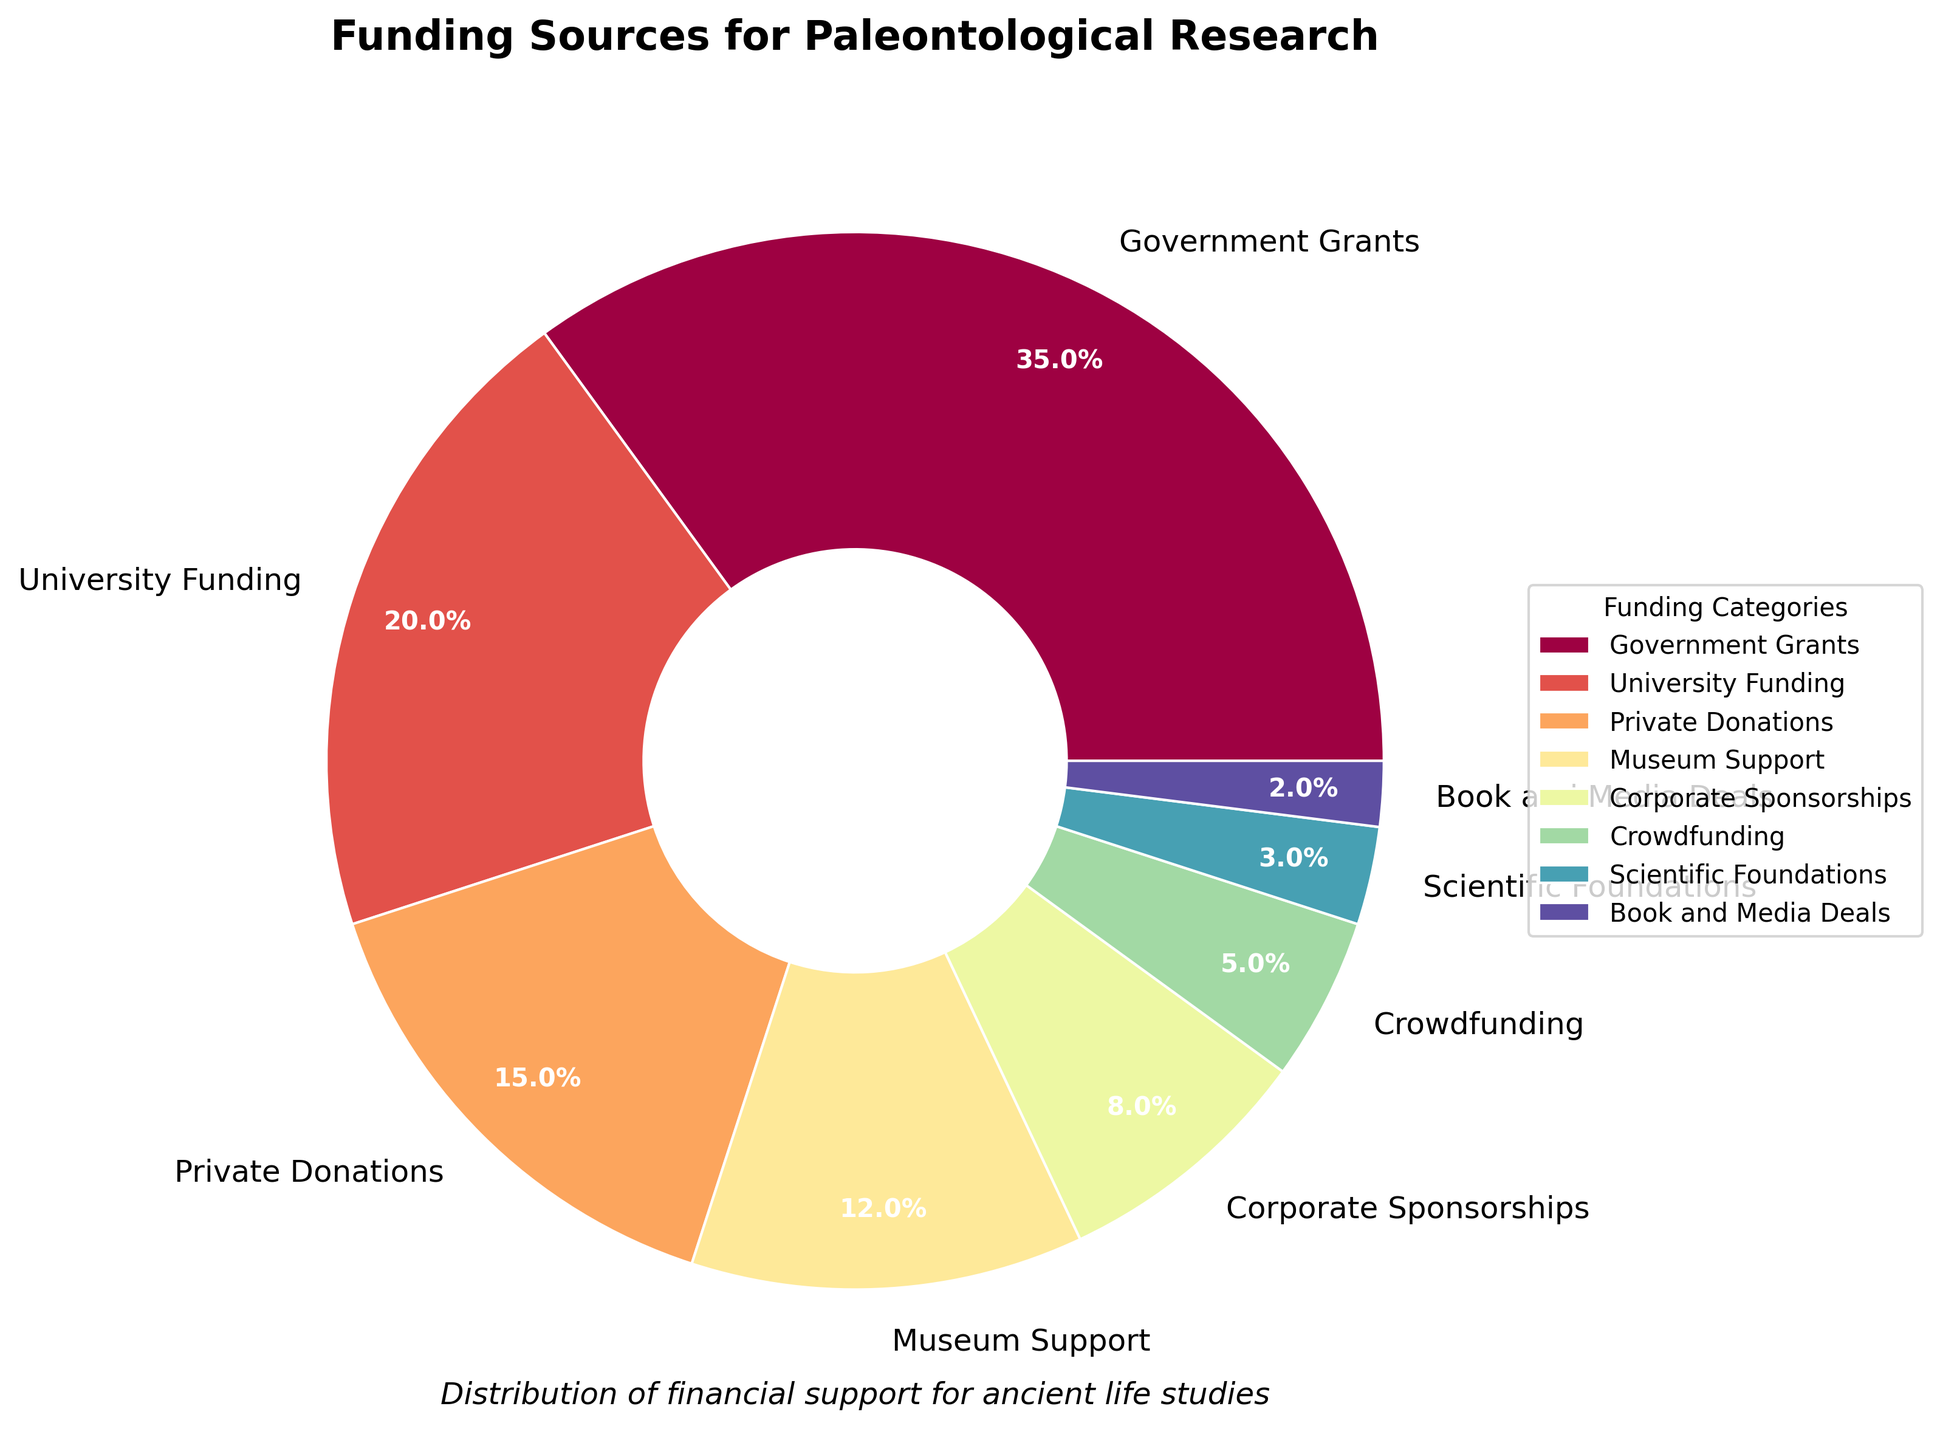What is the largest funding source for paleontological research? The largest funding source is the one with the highest percentage. According to the pie chart, Government Grants constitute 35%, which is the highest.
Answer: Government Grants Which two funding sources together make up more than half of the total funding? To find this, add the percentages of the categories and see if they exceed 50%. The two largest percentages are Government Grants (35%) and University Funding (20%). Their sum is 35% + 20% = 55%, which is more than half.
Answer: Government Grants and University Funding How many funding sources provide less than 10%? Count the funding sources with percentages less than 10%. These are Corporate Sponsorships (8%), Crowdfunding (5%), Scientific Foundations (3%), and Book and Media Deals (2%). There are 4 such sources.
Answer: 4 Which funding source is represented by the smallest wedge in the pie chart? The smallest wedge corresponds to the smallest percentage. According to the pie chart, Book and Media Deals have the smallest wedge with 2%.
Answer: Book and Media Deals What is the total percentage provided by private (non-governmental) sources? Add up the percentages of all private funding sources. These include University Funding (20%), Private Donations (15%), Museum Support (12%), Corporate Sponsorships (8%), Crowdfunding (5%), Scientific Foundations (3%), and Book and Media Deals (2%). The total is 20% + 15% + 12% + 8% + 5% + 3% + 2% = 65%.
Answer: 65% Which funding source is depicted with the color corresponding to the middle hue between red and blue? The color palette is from the 'Spectral' colormap, transitioning through red, yellow, green, and blue. The middle hue between red and blue is generally a shade of green. According to the colors used, Private Donations (15%) are in this middle hue.
Answer: Private Donations Is the percentage of funding from Museum Support greater than that from Corporate Sponsorships? Compare the percentages of Museum Support (12%) and Corporate Sponsorships (8%). Since 12% is greater than 8%, Museum Support is indeed greater.
Answer: Yes What is the difference in percentage points between the largest and smallest funding sources? Subtract the percentage of the smallest source from the largest source. The largest is Government Grants (35%) and the smallest is Book and Media Deals (2%). The difference is 35% - 2% = 33%.
Answer: 33% Which three funding sources together make up exactly 50%? Find a combination of three funding sources whose percentages add up to 50%. University Funding (20%), Private Donations (15%), and Museum Support (12%) sum to 20% + 15% + 12% = 47%, but University Funding (20%), Museum Support (12%), and Corporate Sponsorships (8%) sum to 20% + 12% + 8% = 40%. Correct combination is Government Grants (35%), Crowdfunding (5%), and Private Donations (10%) sum to 35% + 5% + 10% = 50%
Answer: Government Grants, Crowdfunding, and Private Donations 